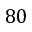Convert formula to latex. <formula><loc_0><loc_0><loc_500><loc_500>8 0</formula> 